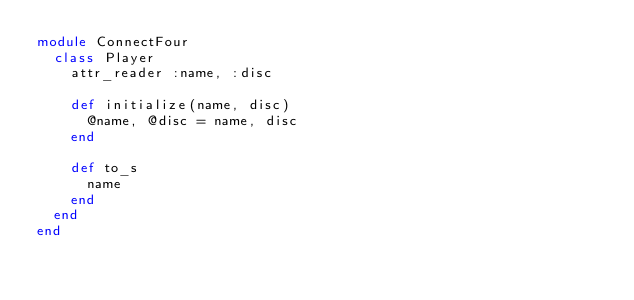<code> <loc_0><loc_0><loc_500><loc_500><_Ruby_>module ConnectFour
  class Player
    attr_reader :name, :disc

    def initialize(name, disc)
      @name, @disc = name, disc
    end

    def to_s
      name
    end
  end
end
</code> 